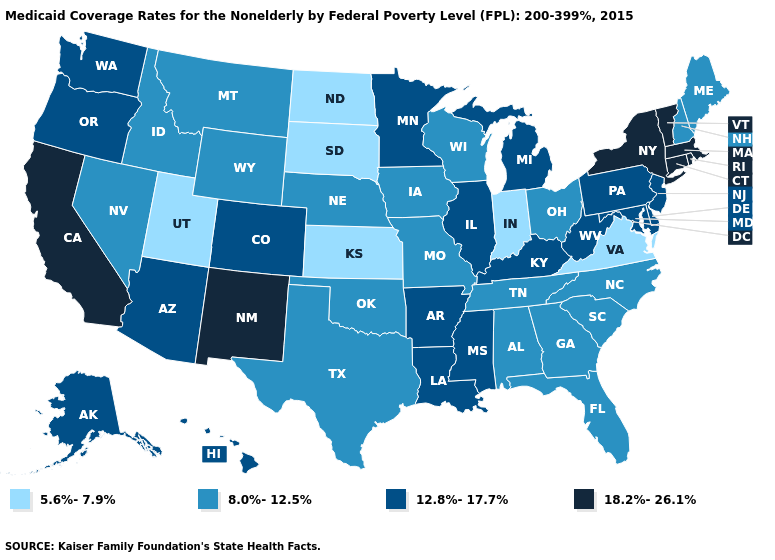Does New Jersey have a lower value than Oregon?
Write a very short answer. No. Does the map have missing data?
Quick response, please. No. Among the states that border Wyoming , does Colorado have the highest value?
Give a very brief answer. Yes. Is the legend a continuous bar?
Keep it brief. No. Among the states that border Connecticut , which have the highest value?
Quick response, please. Massachusetts, New York, Rhode Island. Name the states that have a value in the range 8.0%-12.5%?
Concise answer only. Alabama, Florida, Georgia, Idaho, Iowa, Maine, Missouri, Montana, Nebraska, Nevada, New Hampshire, North Carolina, Ohio, Oklahoma, South Carolina, Tennessee, Texas, Wisconsin, Wyoming. Does the map have missing data?
Give a very brief answer. No. Name the states that have a value in the range 8.0%-12.5%?
Give a very brief answer. Alabama, Florida, Georgia, Idaho, Iowa, Maine, Missouri, Montana, Nebraska, Nevada, New Hampshire, North Carolina, Ohio, Oklahoma, South Carolina, Tennessee, Texas, Wisconsin, Wyoming. Does California have the highest value in the USA?
Concise answer only. Yes. What is the value of Connecticut?
Write a very short answer. 18.2%-26.1%. Which states hav the highest value in the Northeast?
Keep it brief. Connecticut, Massachusetts, New York, Rhode Island, Vermont. How many symbols are there in the legend?
Give a very brief answer. 4. Among the states that border Pennsylvania , which have the lowest value?
Short answer required. Ohio. What is the highest value in the USA?
Be succinct. 18.2%-26.1%. Among the states that border Illinois , which have the lowest value?
Keep it brief. Indiana. 